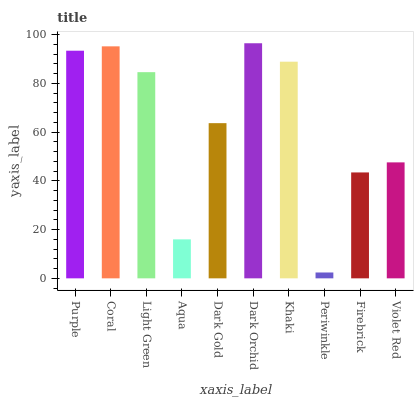Is Coral the minimum?
Answer yes or no. No. Is Coral the maximum?
Answer yes or no. No. Is Coral greater than Purple?
Answer yes or no. Yes. Is Purple less than Coral?
Answer yes or no. Yes. Is Purple greater than Coral?
Answer yes or no. No. Is Coral less than Purple?
Answer yes or no. No. Is Light Green the high median?
Answer yes or no. Yes. Is Dark Gold the low median?
Answer yes or no. Yes. Is Periwinkle the high median?
Answer yes or no. No. Is Coral the low median?
Answer yes or no. No. 